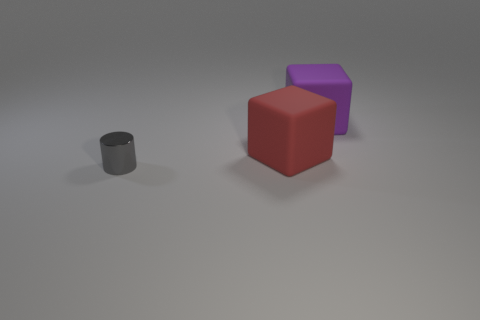Add 2 red things. How many objects exist? 5 Subtract all blocks. How many objects are left? 1 Add 1 tiny shiny things. How many tiny shiny things are left? 2 Add 1 small red matte cylinders. How many small red matte cylinders exist? 1 Subtract 0 gray spheres. How many objects are left? 3 Subtract all tiny gray cylinders. Subtract all small objects. How many objects are left? 1 